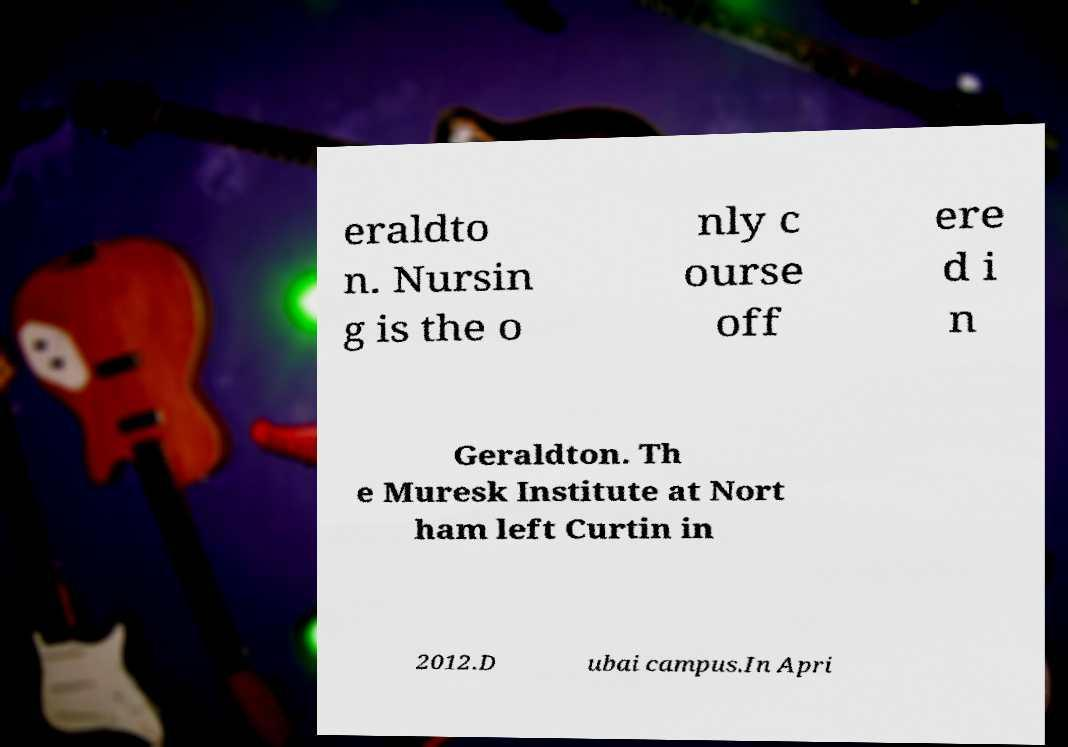For documentation purposes, I need the text within this image transcribed. Could you provide that? eraldto n. Nursin g is the o nly c ourse off ere d i n Geraldton. Th e Muresk Institute at Nort ham left Curtin in 2012.D ubai campus.In Apri 